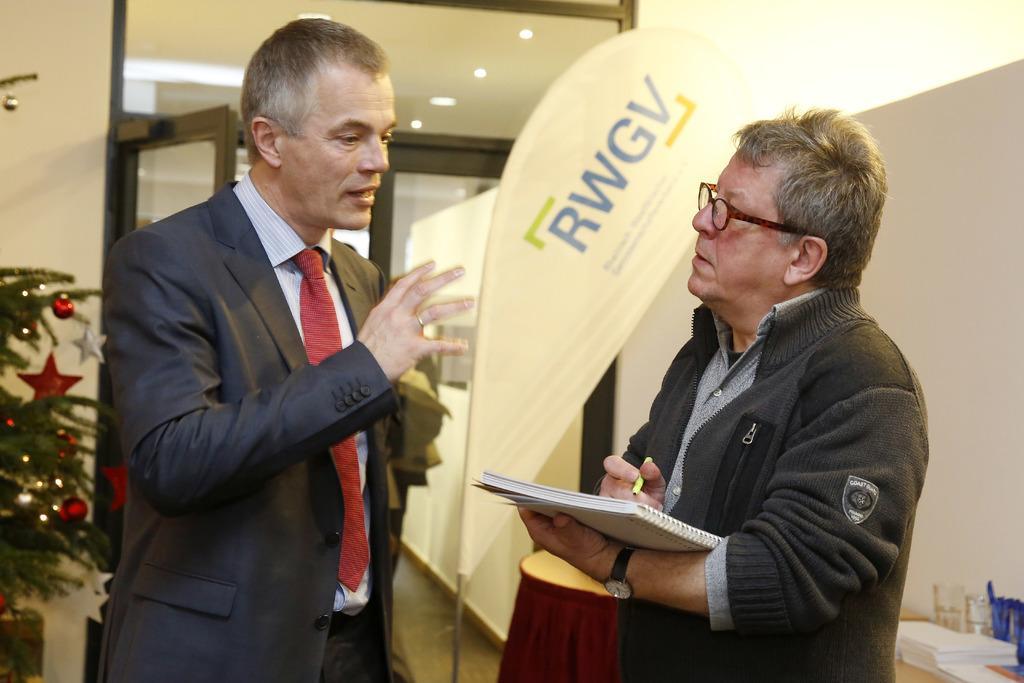Can you describe this image briefly? In this picture we can see few people, on the right side of the image we can see a man, he is holding a book and a pen, in the bottom right hand corner we can see glasses, papers and other things on the table, in the background we can find few lights and a hoarding, on the left side of the image we can see a Christmas tree. 